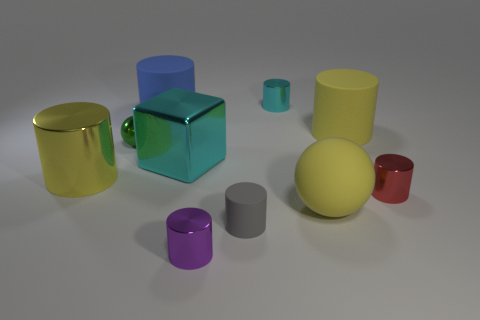Subtract all red cylinders. How many cylinders are left? 6 Add 2 small yellow matte things. How many small yellow matte things exist? 2 Subtract all green spheres. How many spheres are left? 1 Subtract 0 brown cylinders. How many objects are left? 10 Subtract all spheres. How many objects are left? 8 Subtract 2 cylinders. How many cylinders are left? 5 Subtract all blue cylinders. Subtract all brown balls. How many cylinders are left? 6 Subtract all blue balls. How many yellow blocks are left? 0 Subtract all yellow metallic cylinders. Subtract all purple cylinders. How many objects are left? 8 Add 5 big matte cylinders. How many big matte cylinders are left? 7 